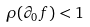Convert formula to latex. <formula><loc_0><loc_0><loc_500><loc_500>\rho ( \partial _ { 0 } f ) < 1</formula> 